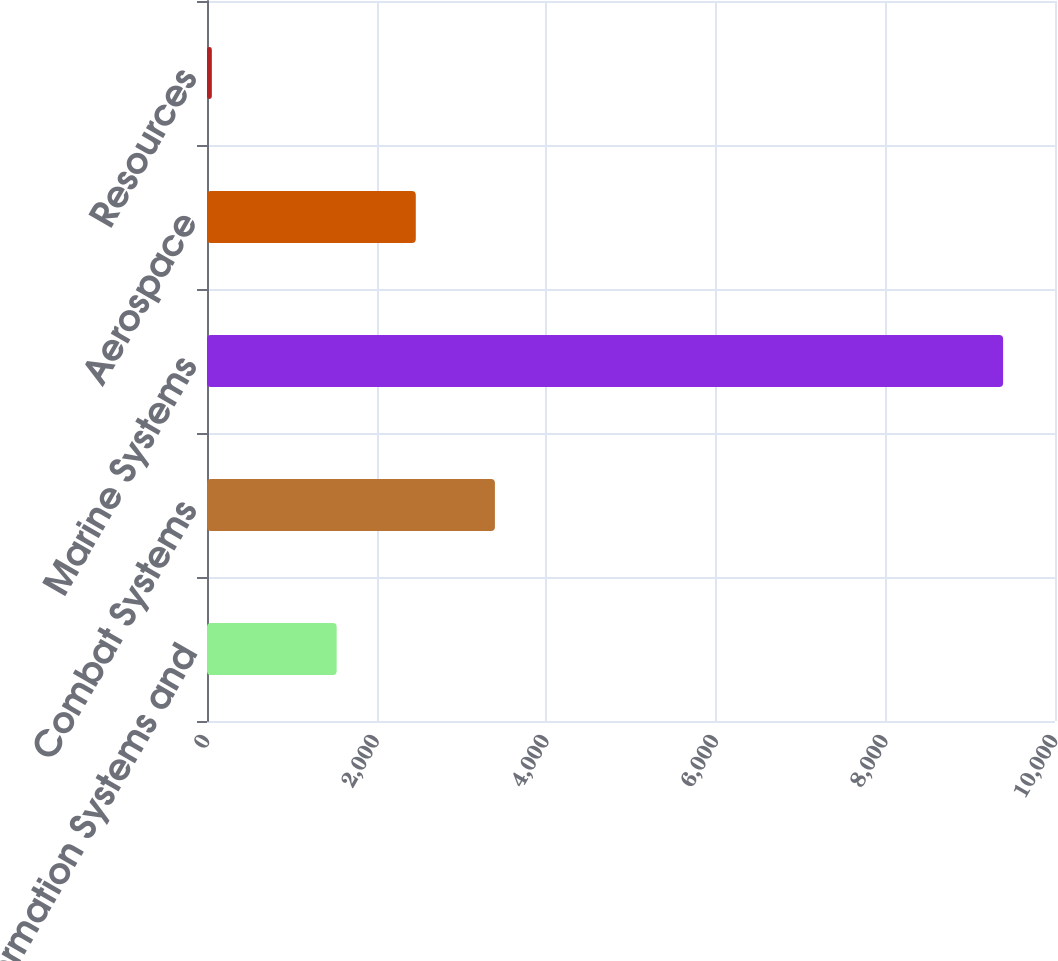Convert chart to OTSL. <chart><loc_0><loc_0><loc_500><loc_500><bar_chart><fcel>Information Systems and<fcel>Combat Systems<fcel>Marine Systems<fcel>Aerospace<fcel>Resources<nl><fcel>1529<fcel>3395.2<fcel>9388<fcel>2462.1<fcel>57<nl></chart> 